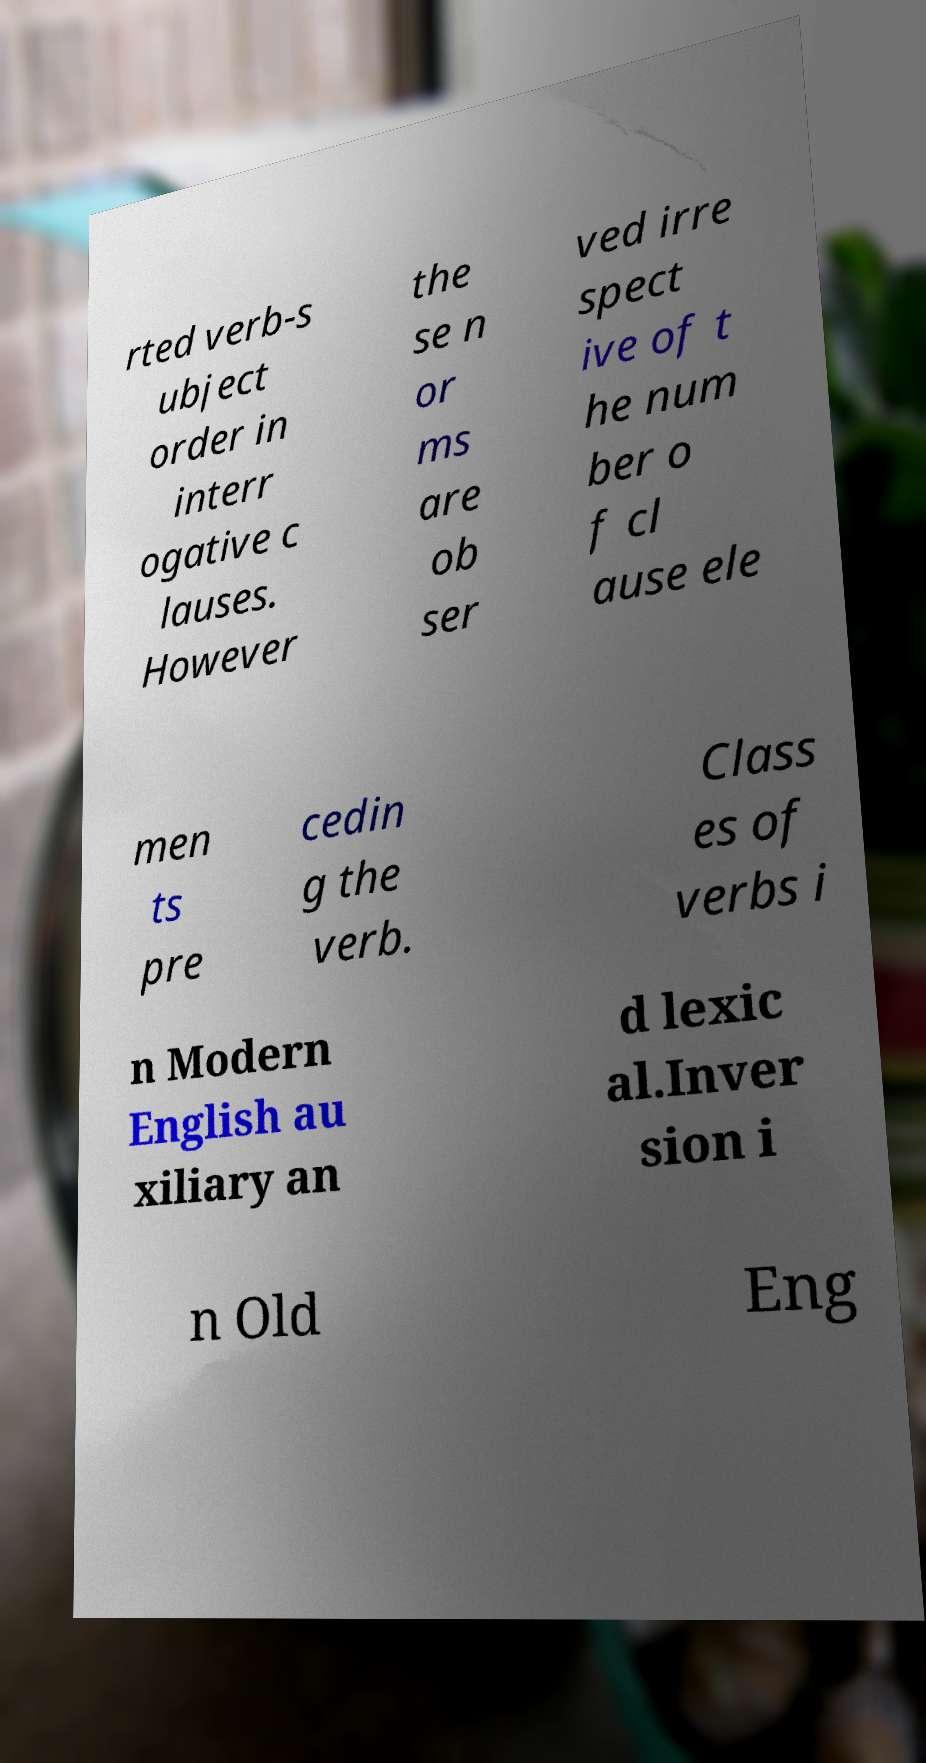Could you assist in decoding the text presented in this image and type it out clearly? rted verb-s ubject order in interr ogative c lauses. However the se n or ms are ob ser ved irre spect ive of t he num ber o f cl ause ele men ts pre cedin g the verb. Class es of verbs i n Modern English au xiliary an d lexic al.Inver sion i n Old Eng 